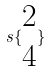<formula> <loc_0><loc_0><loc_500><loc_500>s \{ \begin{matrix} 2 \\ 4 \end{matrix} \}</formula> 